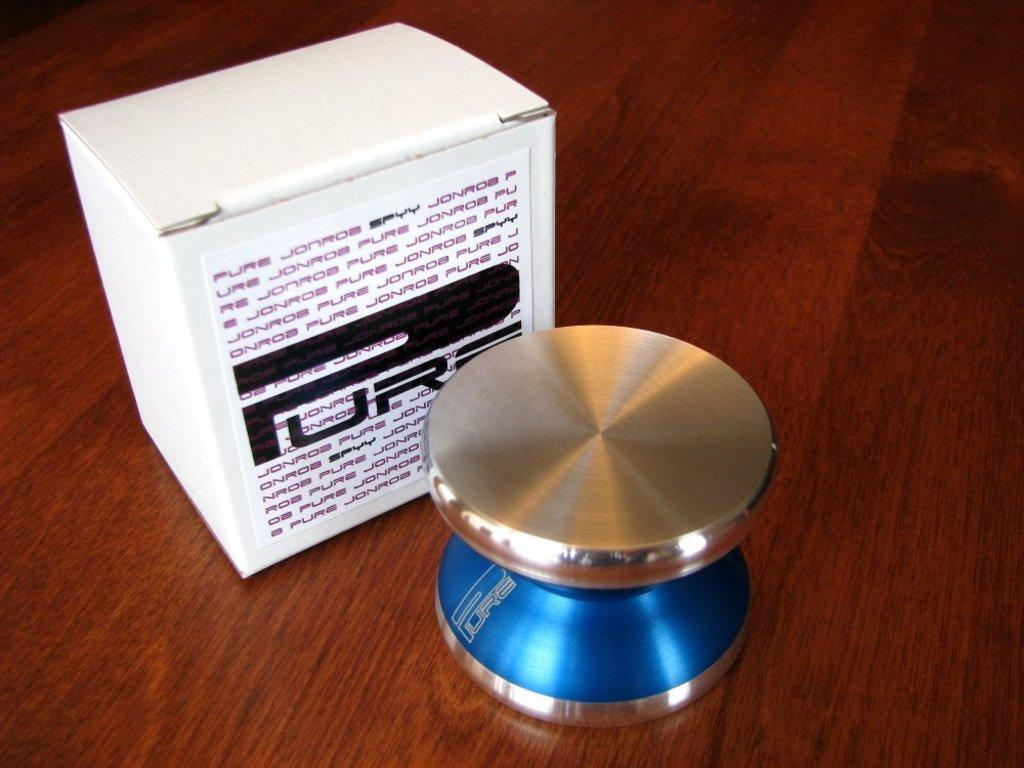<image>
Summarize the visual content of the image. A device that could be either a metallic yo-yo or a tech device sits on a wooden surface and it's box labeled "PURE" sits behind it. 